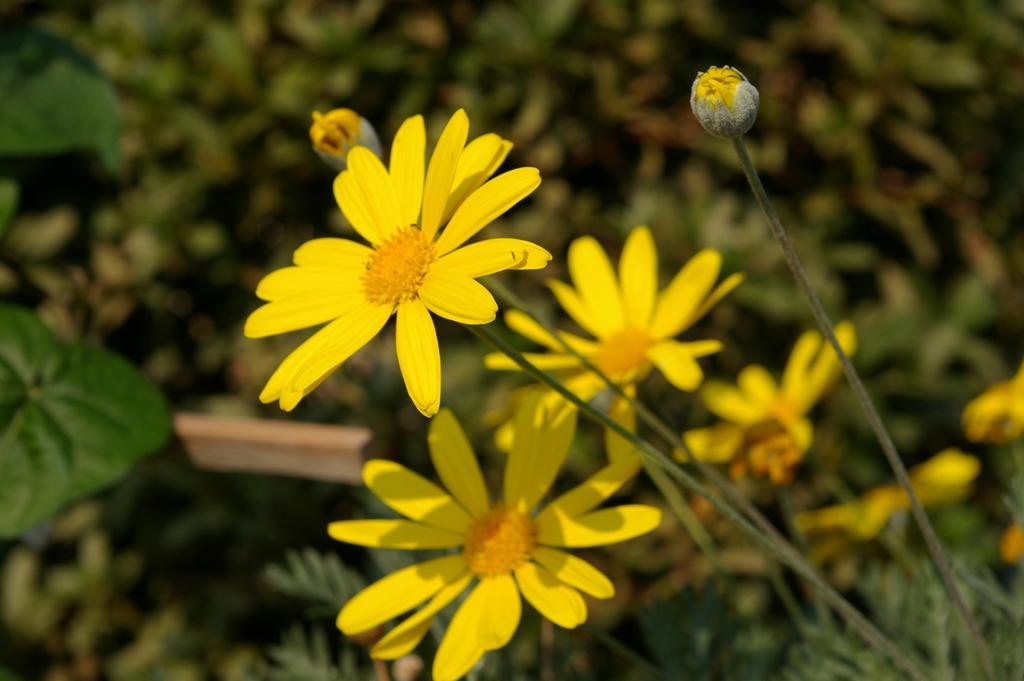Please provide a concise description of this image. In the foreground of this picture, there are yellow flowers and two buds to the plant and in the background, there are plants. 